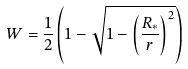<formula> <loc_0><loc_0><loc_500><loc_500>W = \frac { 1 } { 2 } \left ( 1 - \sqrt { 1 - \left ( \frac { R _ { * } } { r } \right ) ^ { 2 } } \right )</formula> 